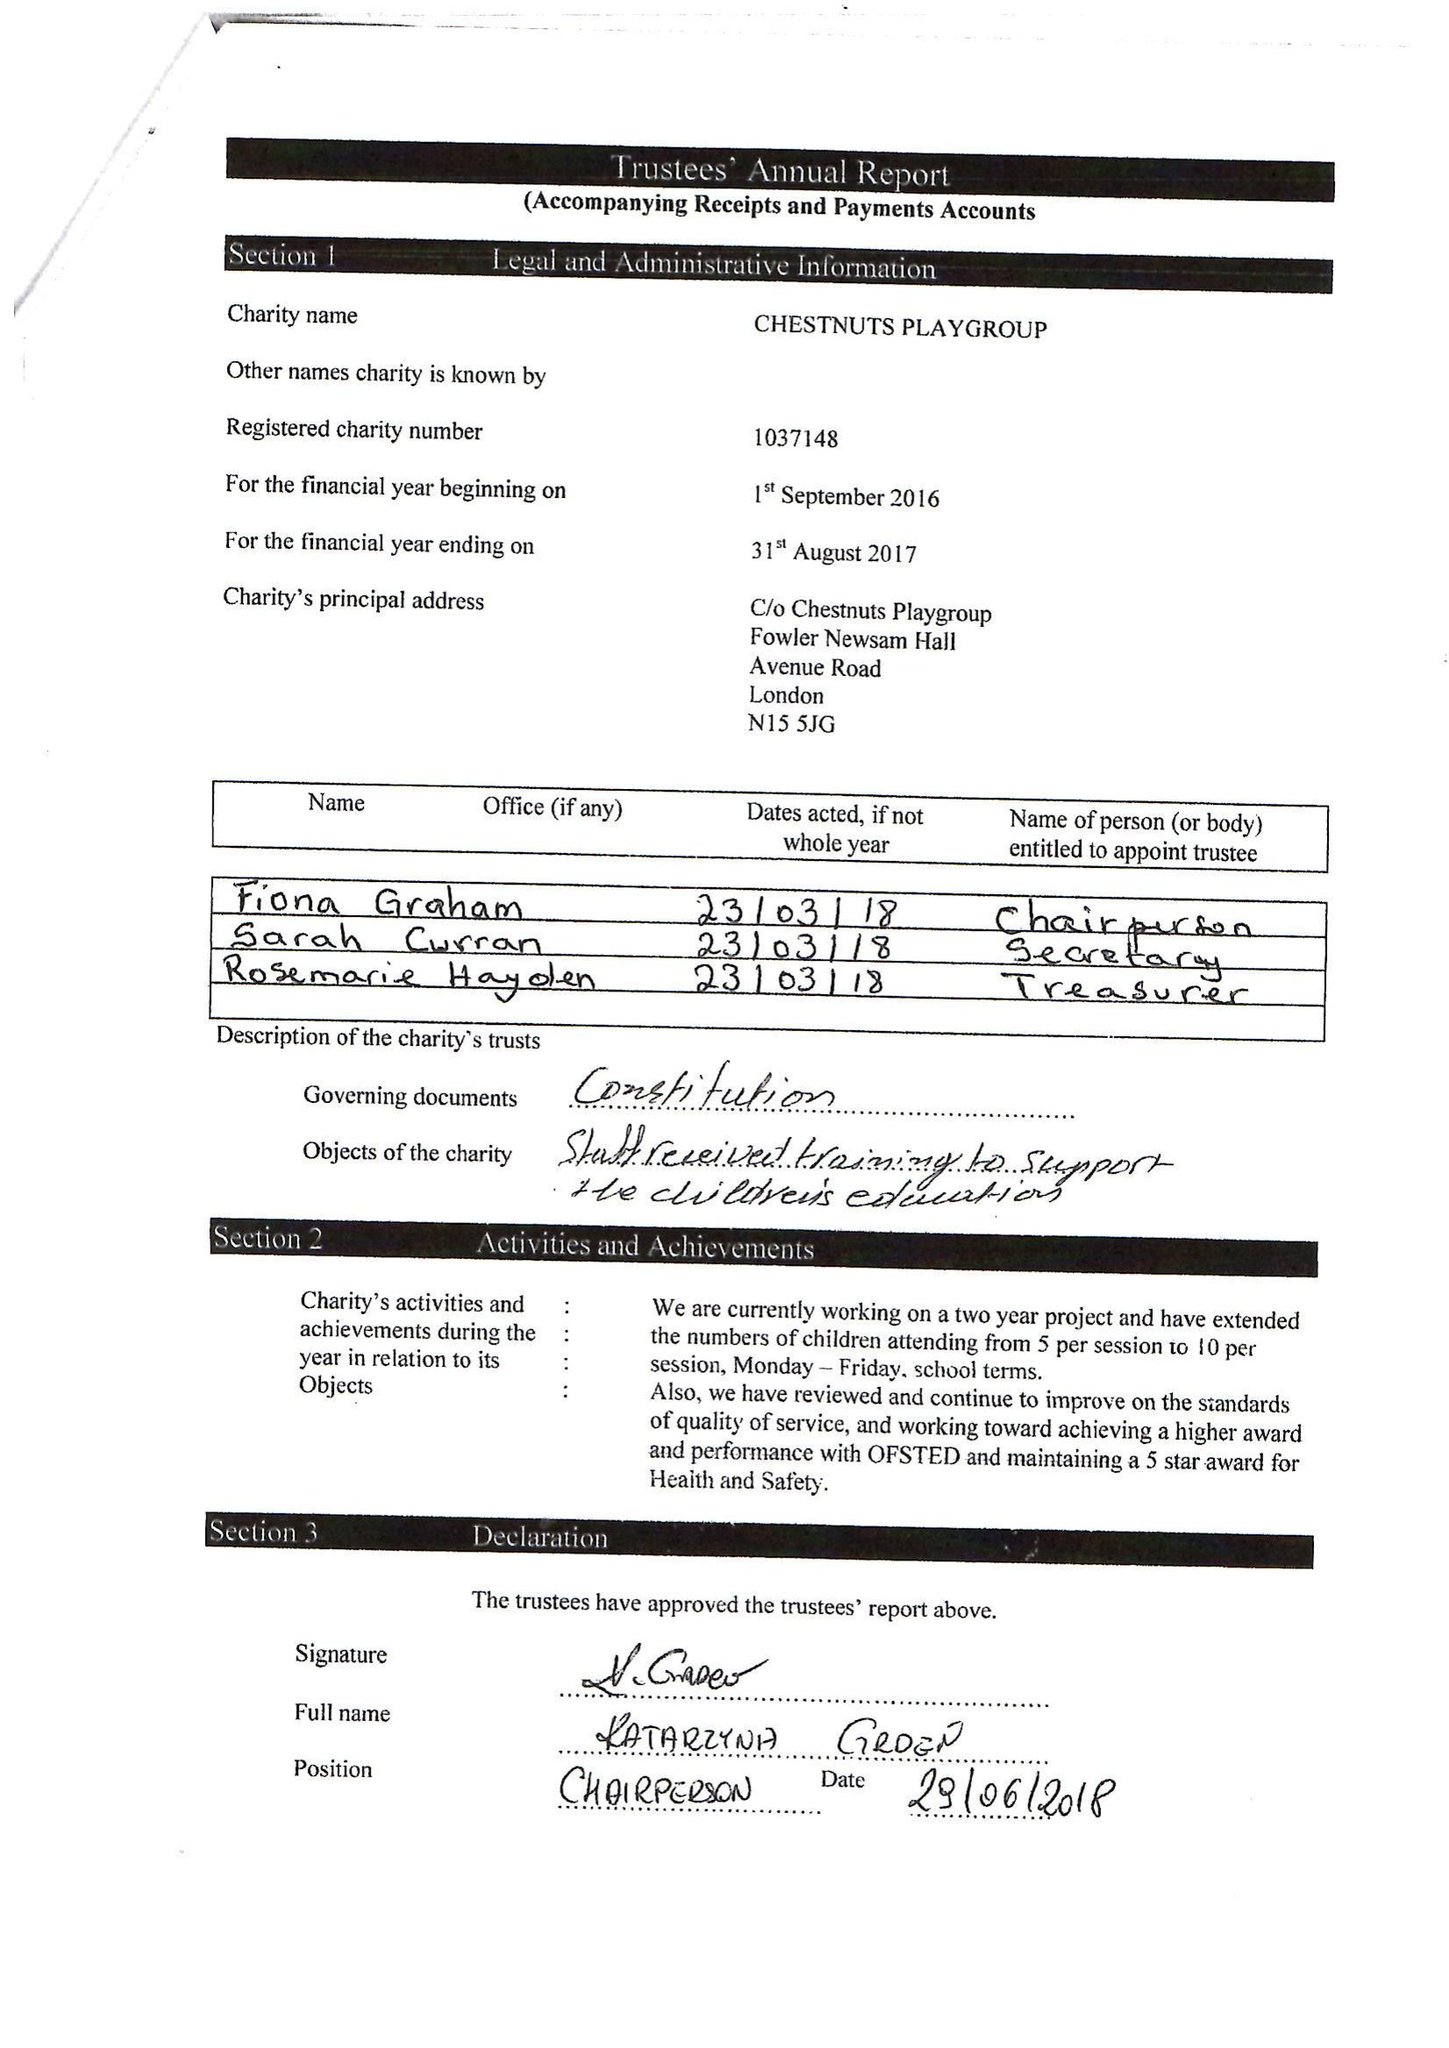What is the value for the spending_annually_in_british_pounds?
Answer the question using a single word or phrase. 111730.00 